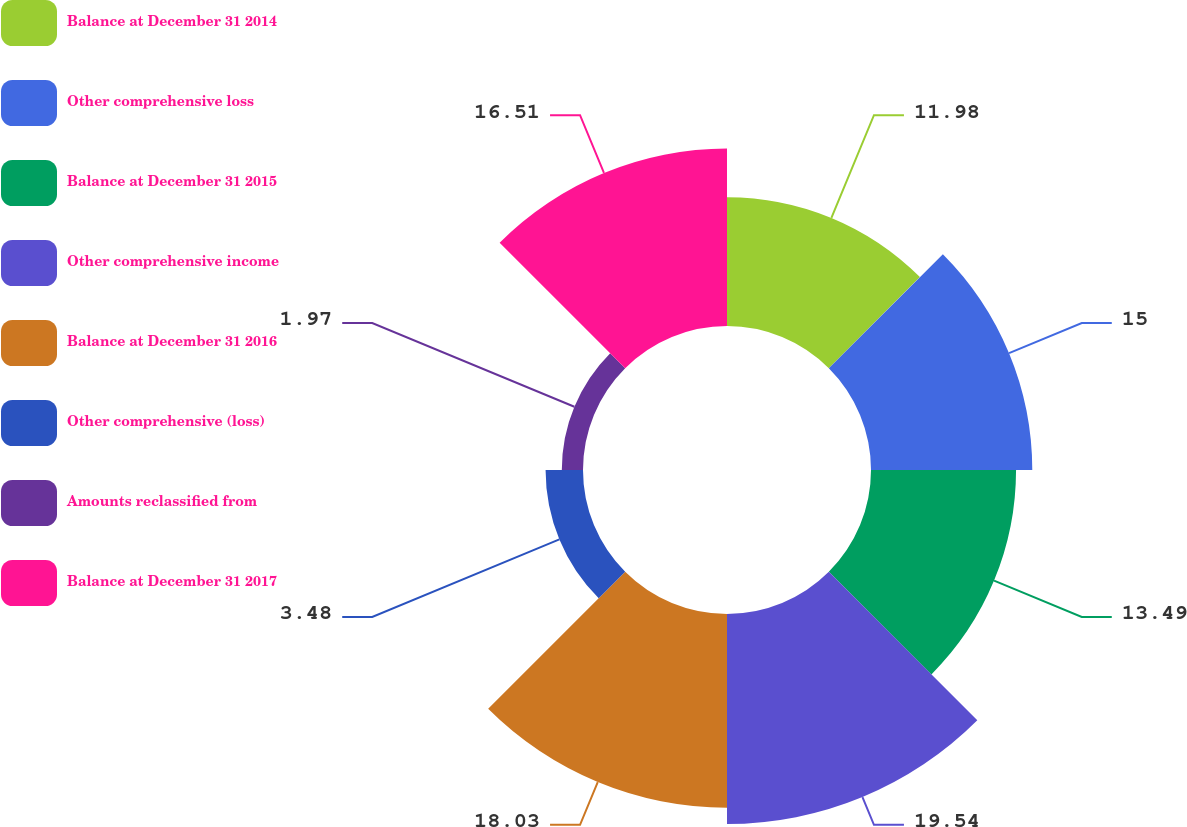Convert chart to OTSL. <chart><loc_0><loc_0><loc_500><loc_500><pie_chart><fcel>Balance at December 31 2014<fcel>Other comprehensive loss<fcel>Balance at December 31 2015<fcel>Other comprehensive income<fcel>Balance at December 31 2016<fcel>Other comprehensive (loss)<fcel>Amounts reclassified from<fcel>Balance at December 31 2017<nl><fcel>11.98%<fcel>15.0%<fcel>13.49%<fcel>19.53%<fcel>18.02%<fcel>3.48%<fcel>1.97%<fcel>16.51%<nl></chart> 